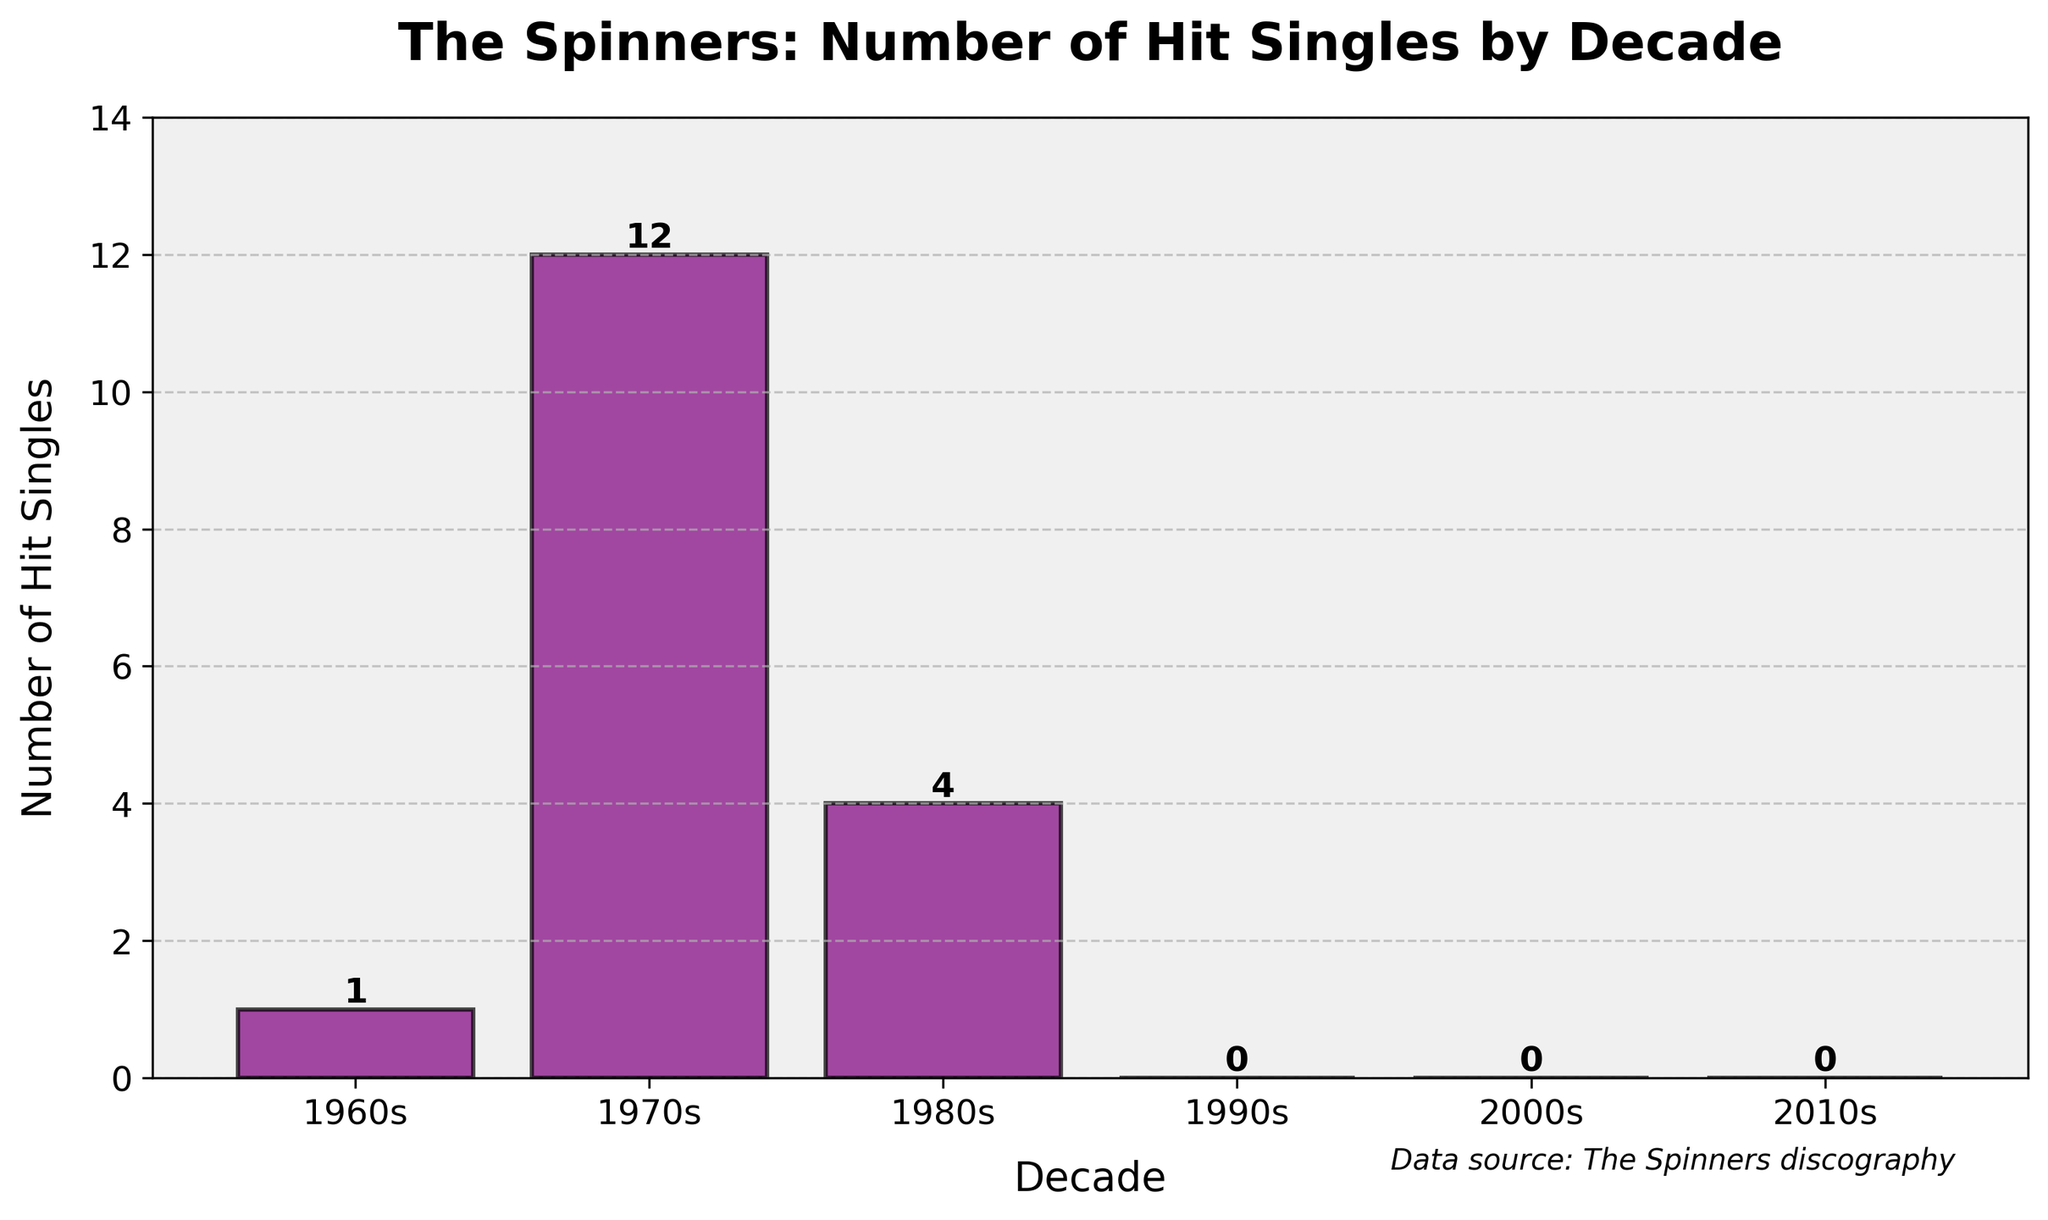How many hit singles did The Spinners have in the 1970s? The bar for the 1970s shows the height representing 12, which means they had 12 hit singles during that decade.
Answer: 12 In which decade did The Spinners have the fewest hit singles? The bars for the 1990s, 2000s, and 2010s are at height 0, indicating that they had no hit singles in these decades. Therefore, all three are the decades with the fewest hit singles.
Answer: 1990s, 2000s, 2010s How many more hit singles did The Spinners have in the 1970s compared to the 1960s? The bar for the 1970s is at 12 and the one for the 1960s is at 1. The difference is 12 - 1 = 11.
Answer: 11 What is the total number of hit singles The Spinners had across all decades? Adding up the number of hit singles from each decade: 1 (1960s) + 12 (1970s) + 4 (1980s) + 0 (1990s) + 0 (2000s) + 0 (2010s) = 17.
Answer: 17 Which decade showed the greatest increase in hit singles compared to the previous decade? The number of hit singles in the 1960s was 1 and in the 1970s it became 12, an increase of 11. Comparing consecutive decades, the increase from the 1960s to the 1970s (11) is the greatest.
Answer: 1970s How does the height of the bar for the 1980s compare to the bar for the 1970s? The height of the bar for the 1980s represents 4 hit singles and the bar for the 1970s represents 12 hit singles. The 1980s bar is shorter.
Answer: The bar for the 1980s is shorter What is the average number of hit singles per decade? Total number of hit singles is 17 and there are 6 decades. The average is 17 / 6 ≈ 2.83.
Answer: 2.83 Which color is used for the bars in the chart? The bars in the chart are colored purple, as observed from the figure itself.
Answer: Purple What is the height of the tallest bar? The tallest bar in the figure is for the 1970s, representing 12 hit singles.
Answer: 12 What's the difference in the number of hit singles between the 1980s and the 1990s? The number of hit singles in the 1980s is 4, and in the 1990s it is 0. The difference is 4 - 0 = 4.
Answer: 4 